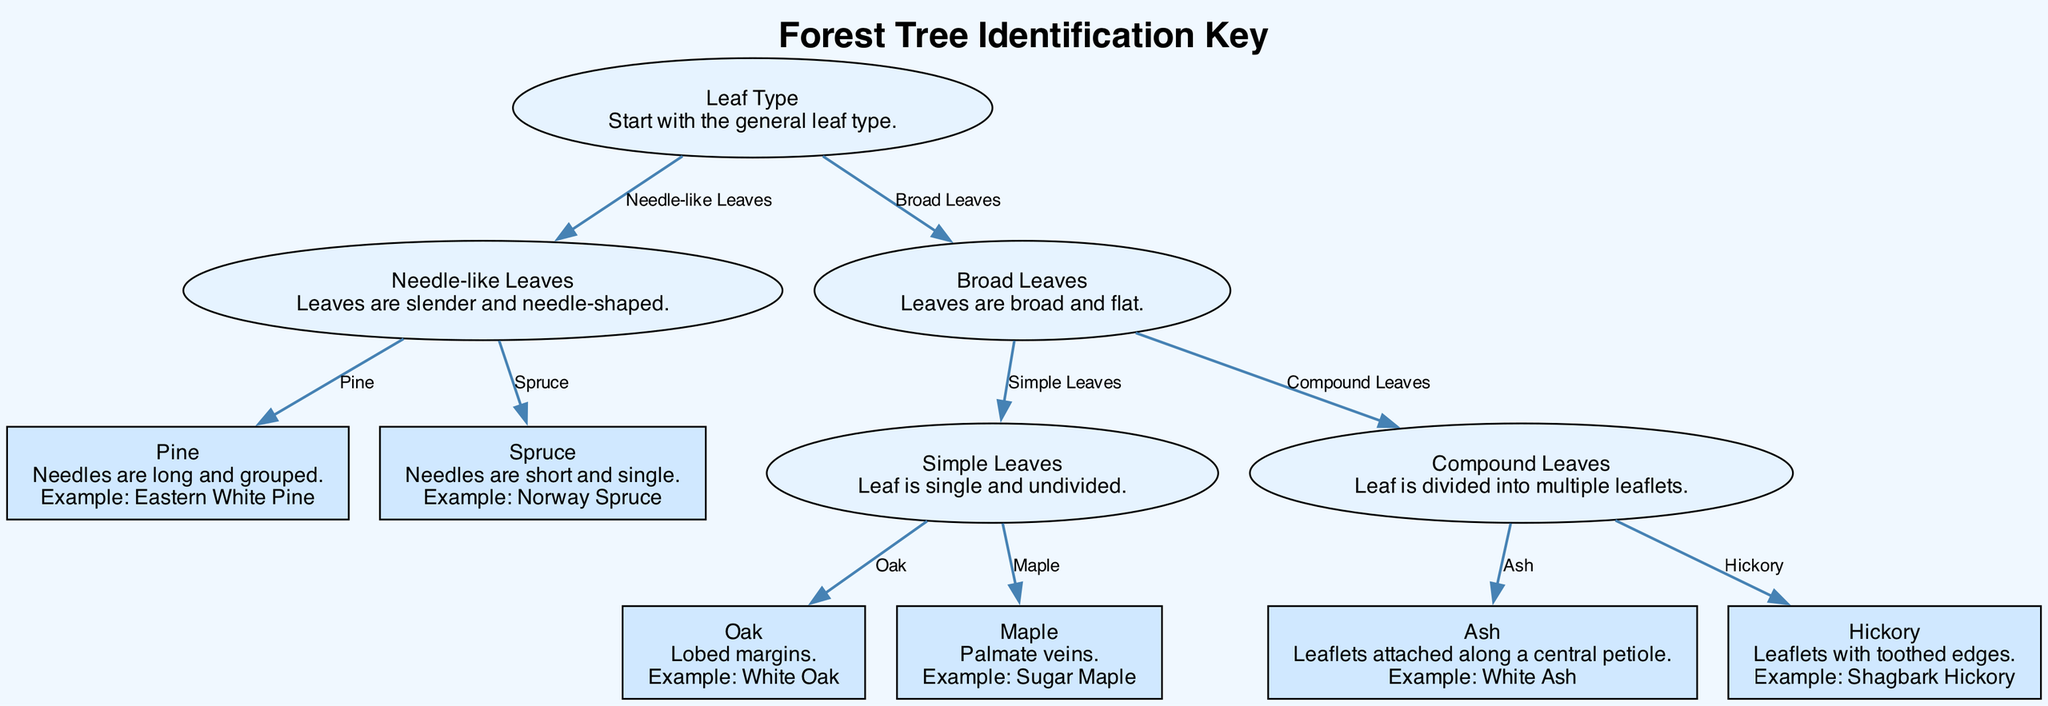What are the two main categories to start identifying trees in this diagram? The diagram begins by categorizing trees based on leaf type, which splits into two main branches: Needle-like Leaves and Broad Leaves.
Answer: Leaf Type Which tree has needle-like leaves that are long and grouped? According to the diagram, the tree with needle-like leaves that are long and grouped is classified as Pine, specifically noted by the example of Eastern White Pine.
Answer: Pine How many types of broad leaves are there in the diagram? The diagram shows two types of broad leaves, which are Simple Leaves (further divided into Oak and Maple) and Compound Leaves (further divided into Ash and Hickory).
Answer: 2 What characteristic defines the Oak tree according to the diagram? The diagram states that the Oak tree is characterized by having lobed margins. This identifying feature helps differentiate it from other trees.
Answer: Lobed margins If a tree has leaflets attached along a central petiole, which tree does it represent? The diagram indicates that if a tree has leaflets attached along a central petiole, it represents the Ash tree, specifically noted with the example of White Ash.
Answer: Ash What type of leaves does the Hickory tree have? According to the diagram, the Hickory tree is identified by having leaflets with toothed edges, which is a distinctive feature of this tree species.
Answer: Toothed edges What example is given for the Maple tree? The diagram provides the example of Sugar Maple specifically to represent the Maple tree and its characteristics.
Answer: Sugar Maple 